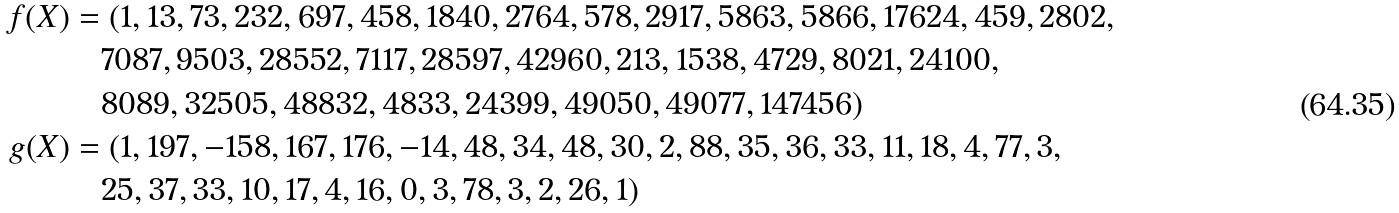<formula> <loc_0><loc_0><loc_500><loc_500>f ( X ) & = ( 1 , 1 3 , 7 3 , 2 3 2 , 6 9 7 , 4 5 8 , 1 8 4 0 , 2 7 6 4 , 5 7 8 , 2 9 1 7 , 5 8 6 3 , 5 8 6 6 , 1 7 6 2 4 , 4 5 9 , 2 8 0 2 , \\ & \quad 7 0 8 7 , 9 5 0 3 , 2 8 5 5 2 , 7 1 1 7 , 2 8 5 9 7 , 4 2 9 6 0 , 2 1 3 , 1 5 3 8 , 4 7 2 9 , 8 0 2 1 , 2 4 1 0 0 , \\ & \quad 8 0 8 9 , 3 2 5 0 5 , 4 8 8 3 2 , 4 8 3 3 , 2 4 3 9 9 , 4 9 0 5 0 , 4 9 0 7 7 , 1 4 7 4 5 6 ) \\ g ( X ) & = ( 1 , 1 9 7 , - 1 5 8 , 1 6 7 , 1 7 6 , - 1 4 , 4 8 , 3 4 , 4 8 , 3 0 , 2 , 8 8 , 3 5 , 3 6 , 3 3 , 1 1 , 1 8 , 4 , 7 7 , 3 , \\ & \quad 2 5 , 3 7 , 3 3 , 1 0 , 1 7 , 4 , 1 6 , 0 , 3 , 7 8 , 3 , 2 , 2 6 , 1 )</formula> 